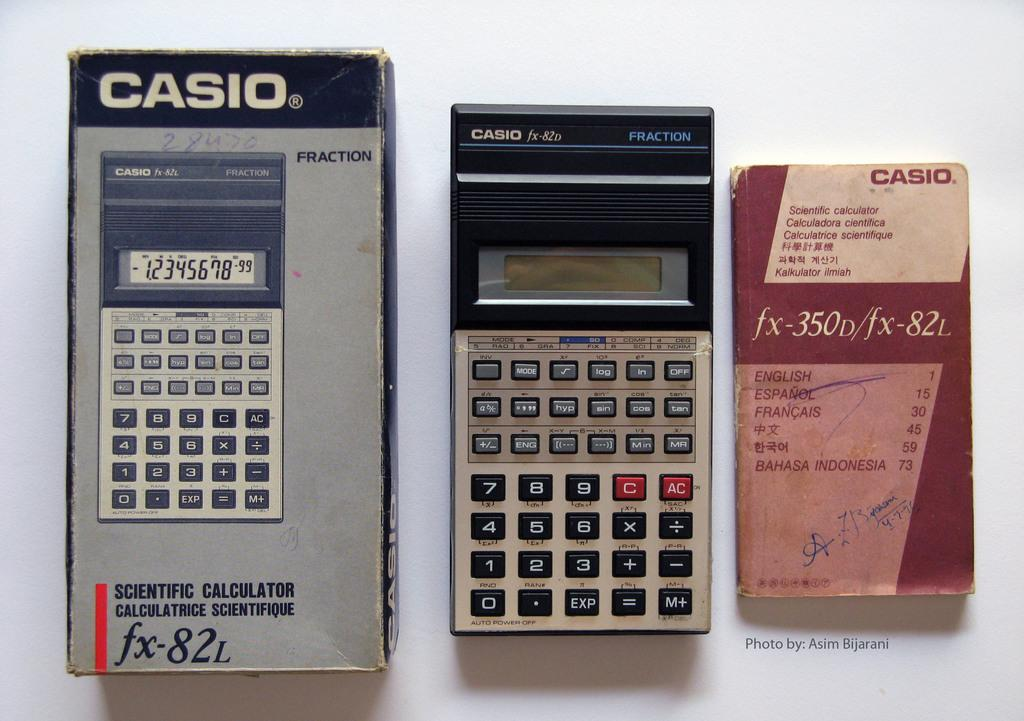Provide a one-sentence caption for the provided image. A few casio items showcased from largest to smallest. 